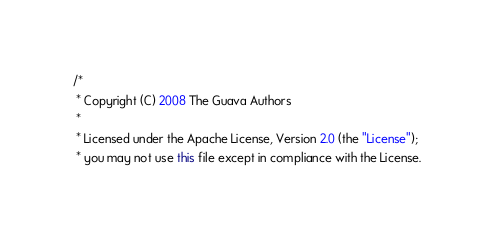Convert code to text. <code><loc_0><loc_0><loc_500><loc_500><_Java_>/*
 * Copyright (C) 2008 The Guava Authors
 *
 * Licensed under the Apache License, Version 2.0 (the "License");
 * you may not use this file except in compliance with the License.</code> 